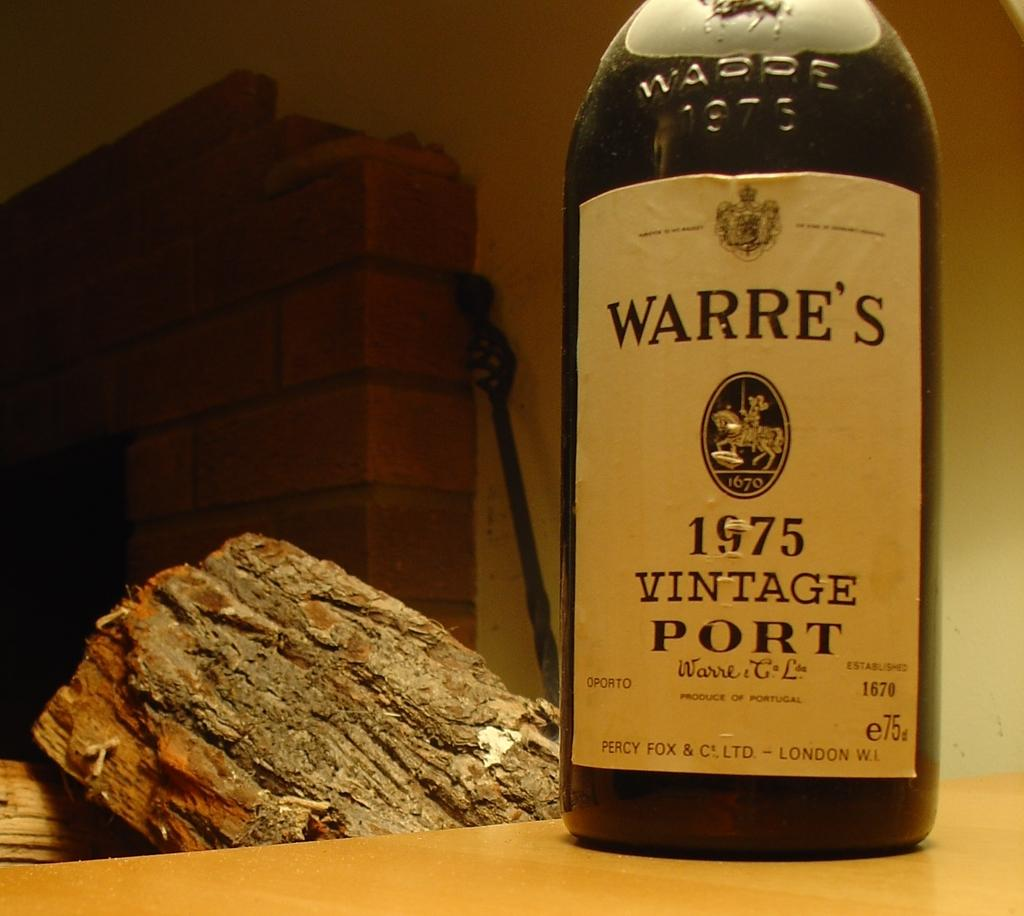Provide a one-sentence caption for the provided image. A glass bottle of vintage Port wine standing in front of a wooden log and fireplace. 